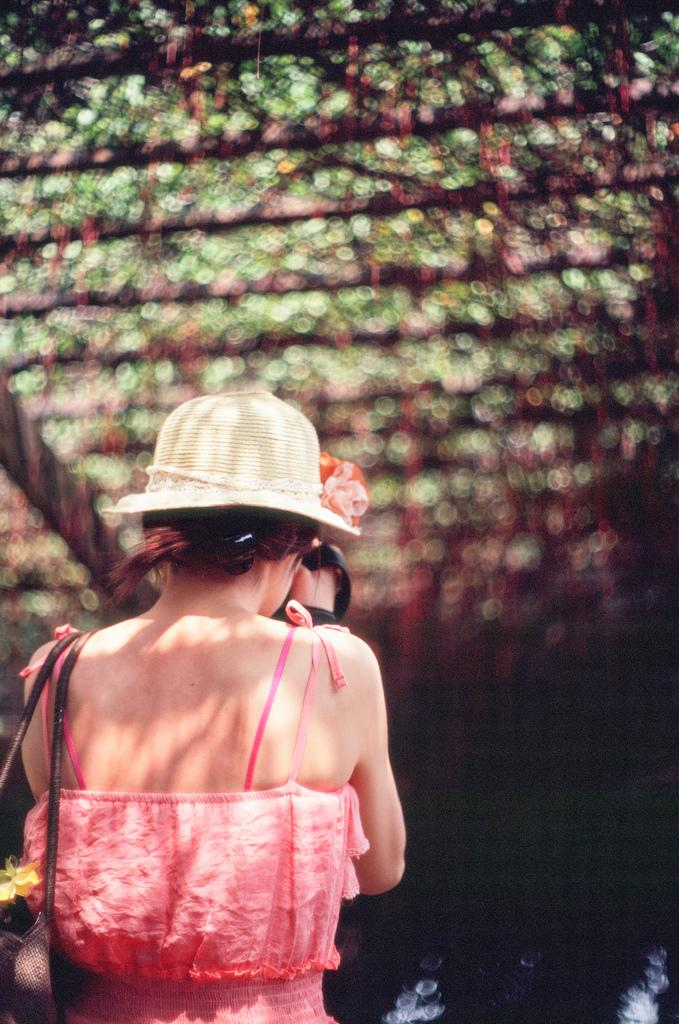Who is the main subject in the image? There is a girl in the image. Where is the girl located in the image? The girl is on the left side of the image. What can be observed about the background in the image? The background area of the image is blurred. What type of lunch is the girl eating in the image? There is no indication of the girl eating lunch in the image. Can you tell me how many boxes are visible in the image? There are no boxes present in the image. 